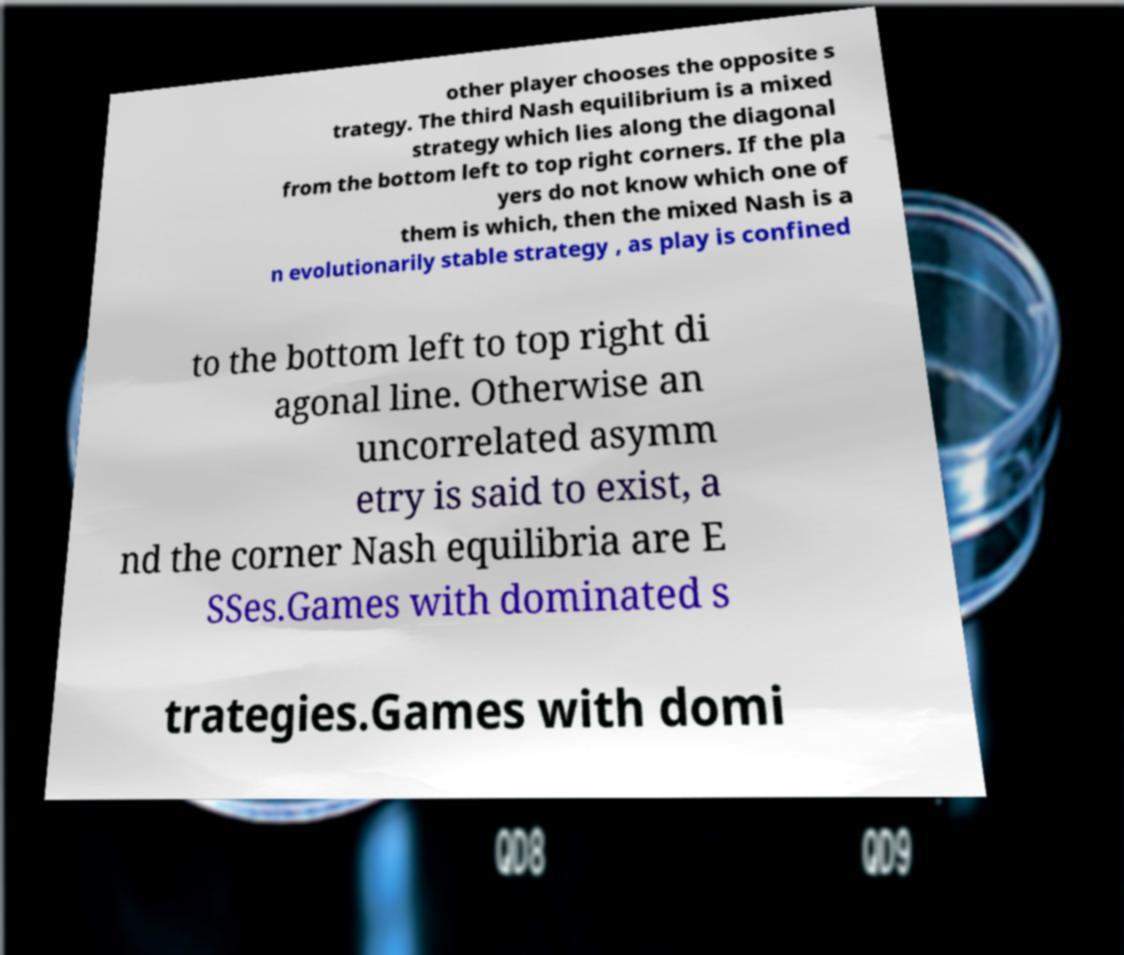For documentation purposes, I need the text within this image transcribed. Could you provide that? other player chooses the opposite s trategy. The third Nash equilibrium is a mixed strategy which lies along the diagonal from the bottom left to top right corners. If the pla yers do not know which one of them is which, then the mixed Nash is a n evolutionarily stable strategy , as play is confined to the bottom left to top right di agonal line. Otherwise an uncorrelated asymm etry is said to exist, a nd the corner Nash equilibria are E SSes.Games with dominated s trategies.Games with domi 